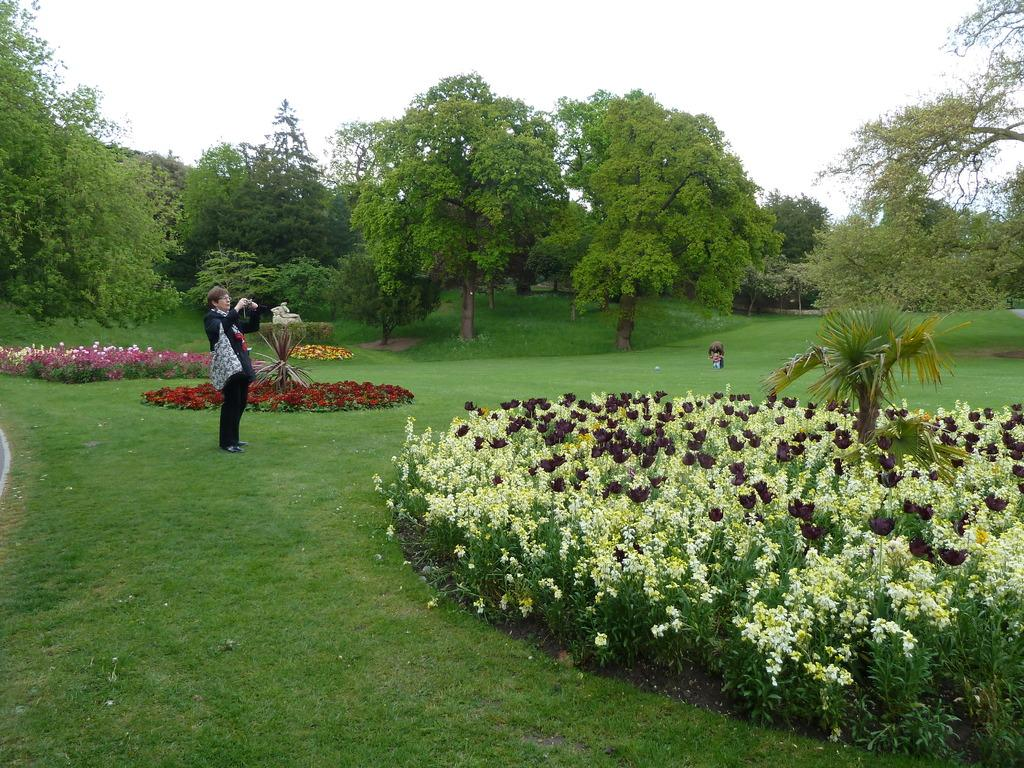What is the person in the image holding? There is a person holding an object in the image. What type of natural environment is depicted in the image? The image features trees, plants, flower plants, grass, and the sky, indicating a natural environment. What type of sugar can be seen in the image? There is no sugar present in the image. Can you describe the tiger's behavior in the image? There is no tiger present in the image. 